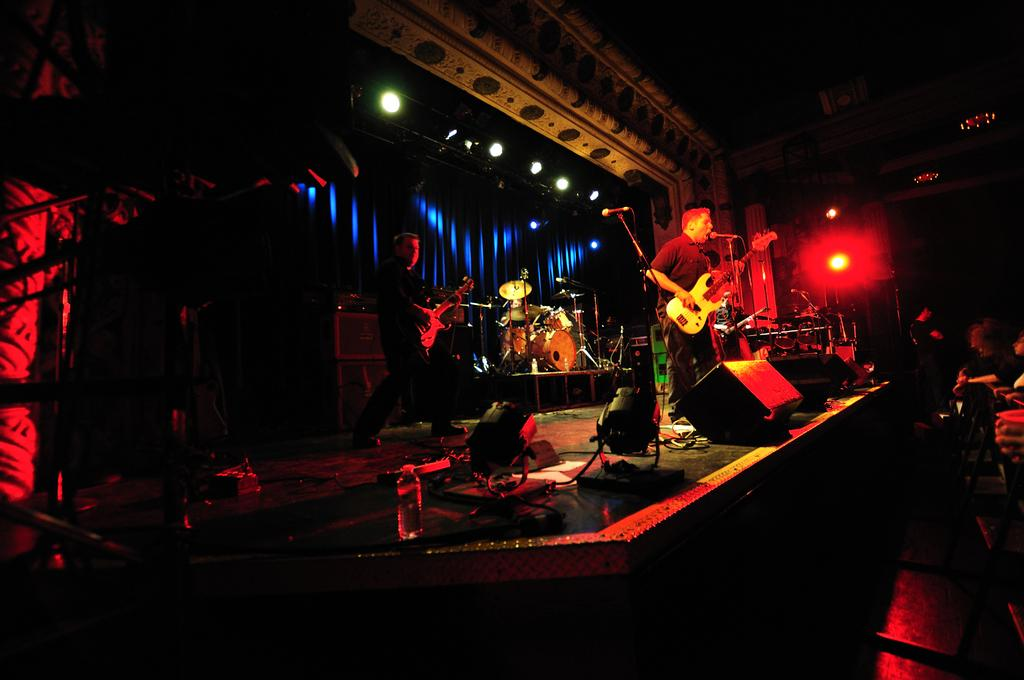How many people are in the image? There are two persons in the image. What are the persons doing in the image? The persons are playing guitar. What object is present for amplifying sound in the image? There is a microphone in the image. What other musical instruments can be seen in the image? There are musical instruments in the image. What color is the curtain in the image? There is a blue curtain in the image. What type of lighting is visible in the image? There are focusing lights visible in the image. Can you see any fairies playing with the guitar in the image? There are no fairies present in the image; it features two persons playing guitar. How does the breath of the musicians affect the sound of the instruments in the image? The image does not show the musicians' breath or how it might affect the sound of the instruments. 